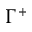<formula> <loc_0><loc_0><loc_500><loc_500>\Gamma ^ { + }</formula> 